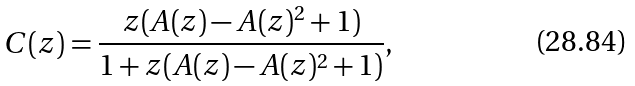Convert formula to latex. <formula><loc_0><loc_0><loc_500><loc_500>C ( z ) = \frac { z ( A ( z ) - A ( z ) ^ { 2 } + 1 ) } { 1 + z ( A ( z ) - A ( z ) ^ { 2 } + 1 ) } ,</formula> 